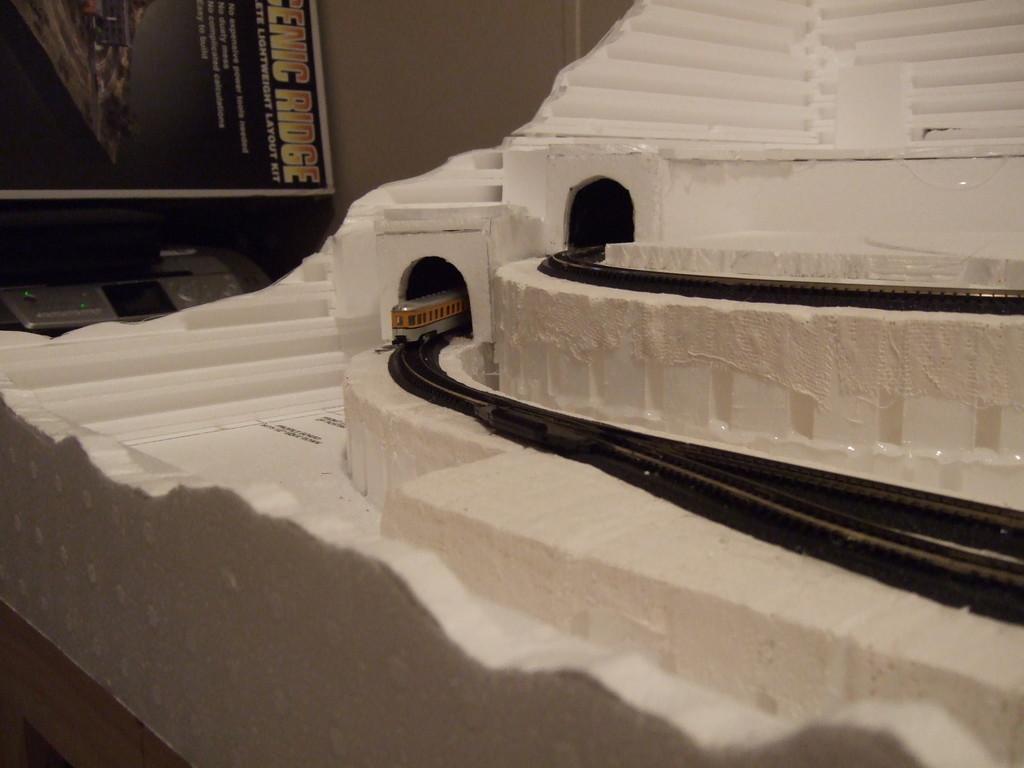How would you summarize this image in a sentence or two? On the left side, there is a model train on the railway track. Above this railway track, there is another railway track. In the background, there is a screen and there is a wall. 